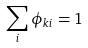<formula> <loc_0><loc_0><loc_500><loc_500>\sum _ { i } \phi _ { k i } = 1</formula> 